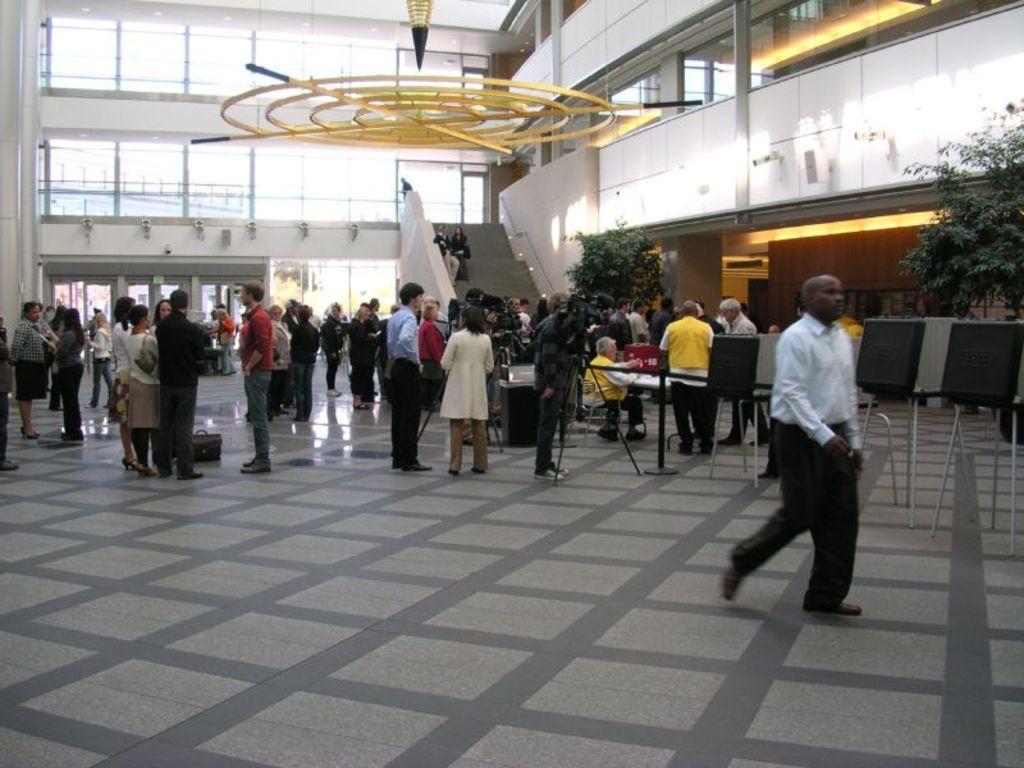In one or two sentences, can you explain what this image depicts? In this picture there are group of persons standing and walking. In the center there is a person standing and holding a camera in his hand. In the background there are person sitting on stage and there are plants there are windows and on the right side there are tables and there is a wall. 